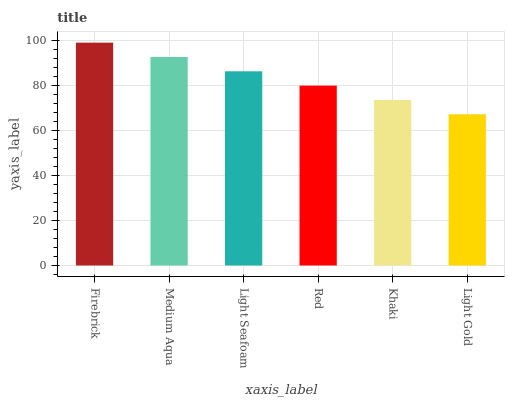Is Light Gold the minimum?
Answer yes or no. Yes. Is Firebrick the maximum?
Answer yes or no. Yes. Is Medium Aqua the minimum?
Answer yes or no. No. Is Medium Aqua the maximum?
Answer yes or no. No. Is Firebrick greater than Medium Aqua?
Answer yes or no. Yes. Is Medium Aqua less than Firebrick?
Answer yes or no. Yes. Is Medium Aqua greater than Firebrick?
Answer yes or no. No. Is Firebrick less than Medium Aqua?
Answer yes or no. No. Is Light Seafoam the high median?
Answer yes or no. Yes. Is Red the low median?
Answer yes or no. Yes. Is Khaki the high median?
Answer yes or no. No. Is Medium Aqua the low median?
Answer yes or no. No. 